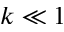<formula> <loc_0><loc_0><loc_500><loc_500>k \ll 1</formula> 